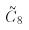Convert formula to latex. <formula><loc_0><loc_0><loc_500><loc_500>\tilde { C } _ { 8 }</formula> 